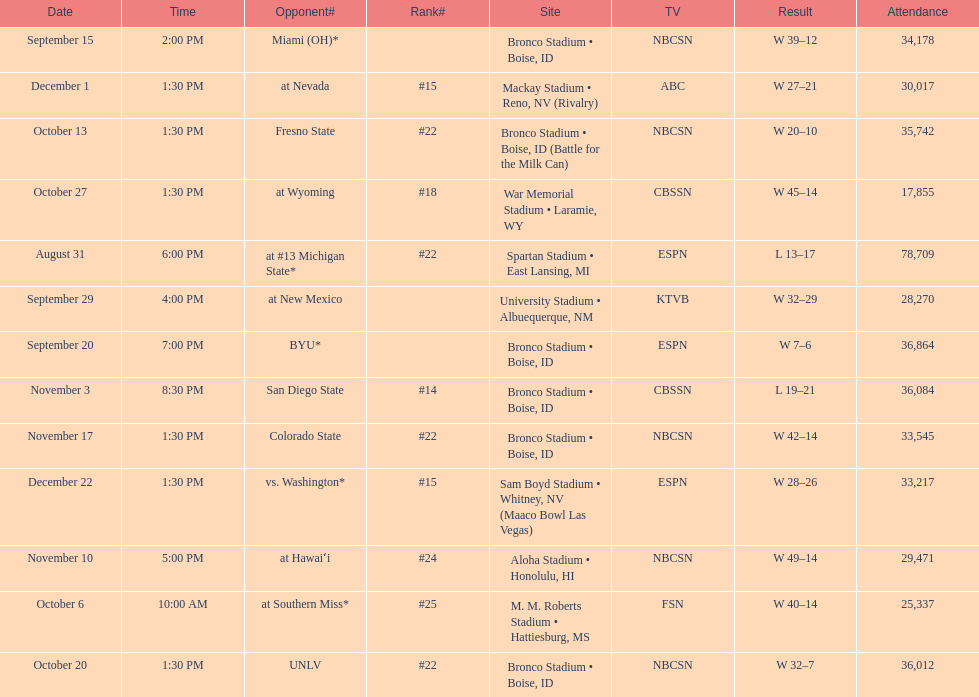Which team has the highest rank among those listed? San Diego State. 